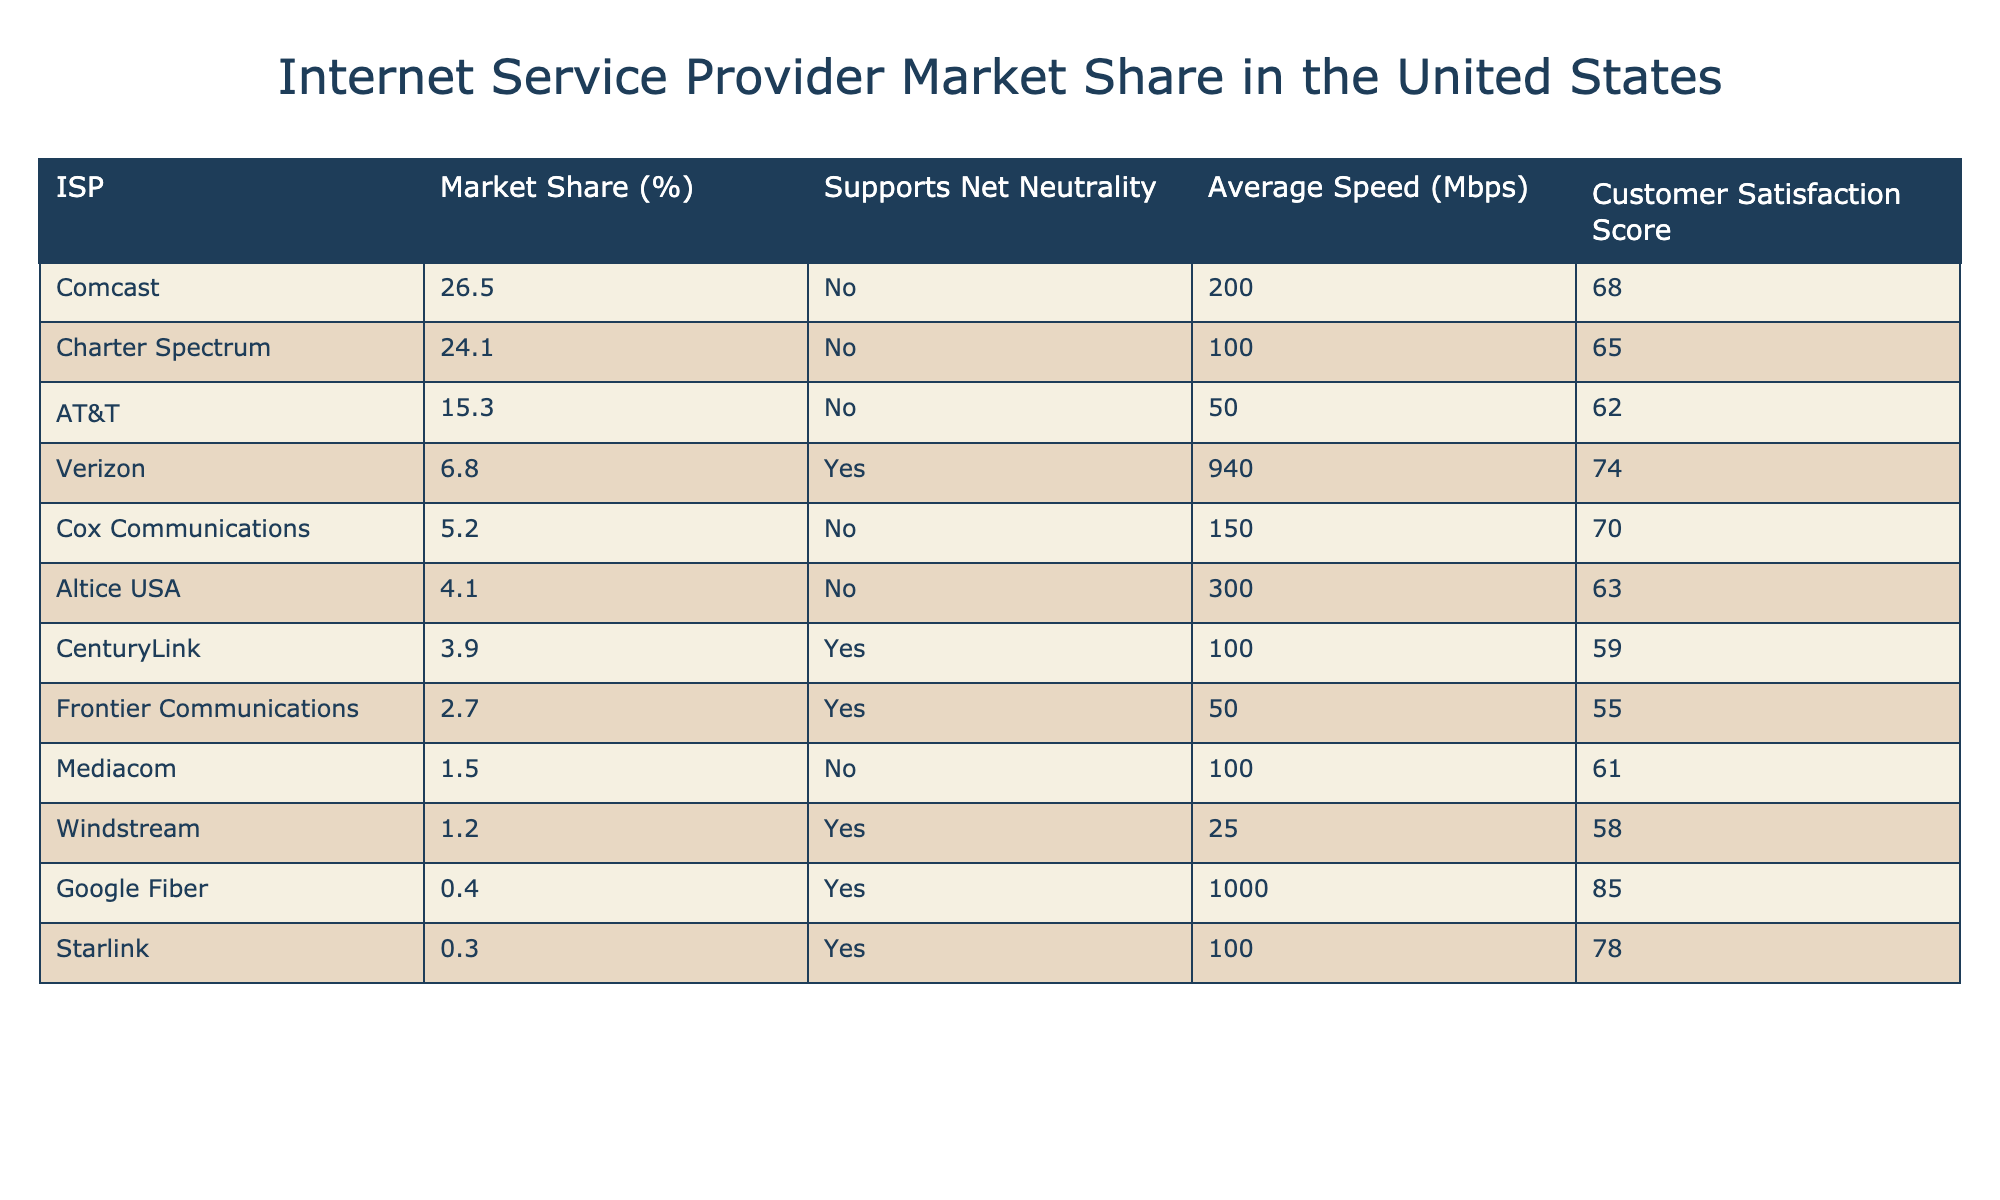What is the market share percentage of Comcast? The table lists the market share percentages for each ISP, and Comcast has a market share of 26.5%.
Answer: 26.5% Which ISP has the highest average speed? By looking at the average speeds in the table, Verizon has the highest average speed at 940 Mbps.
Answer: Verizon How many ISPs support net neutrality? The table indicates which ISPs support net neutrality. There are 5 ISPs listed that support it: Verizon, CenturyLink, Frontier Communications, Google Fiber, and Starlink.
Answer: 5 What is the customer satisfaction score for Charter Spectrum? The table directly shows that Charter Spectrum has a customer satisfaction score of 65.
Answer: 65 What is the difference in market share between Comcast and AT&T? Comcast has a market share of 26.5% and AT&T has 15.3%. The difference is 26.5% - 15.3% = 11.2%.
Answer: 11.2% Which ISP has the lowest customer satisfaction score? Looking at the customer satisfaction scores, Frontier Communications has the lowest score at 55.
Answer: Frontier Communications What is the average market share percentage of the ISPs that support net neutrality? The ISPs that support net neutrality are Verizon, CenturyLink, Frontier Communications, Google Fiber, and Starlink. Their market shares are 6.8%, 3.9%, 2.7%, 0.4%, and 0.3%. The average market share is (6.8 + 3.9 + 2.7 + 0.4 + 0.3) / 5 = 2.82%.
Answer: 2.82% Is there any ISP with a market share of less than 5% that supports net neutrality? Among the ISPs listed, only Windstream and the others have less than 5% market share, but Windstream supports net neutrality, while the rest do not. Thus, Windstream fulfills the criteria.
Answer: Yes Which ISP with the lowest market share has the highest customer satisfaction score? The ISPs with the lowest market shares are Mediacom (1.5%) and Windstream (1.2%). Mediacom has a satisfaction score of 61 and Windstream has 58. Therefore, Mediacom has the highest customer satisfaction score among them.
Answer: Mediacom If you were to combine the market shares of all ISPs that do not support net neutrality, what would that total be? The ISPs that do not support net neutrality are Comcast, Charter Spectrum, AT&T, Cox Communications, Altice USA, Mediacom. Their market shares are 26.5%, 24.1%, 15.3%, 5.2%, 4.1%, and 1.5%, respectively. Summing these gives a total of 76.7%.
Answer: 76.7% 